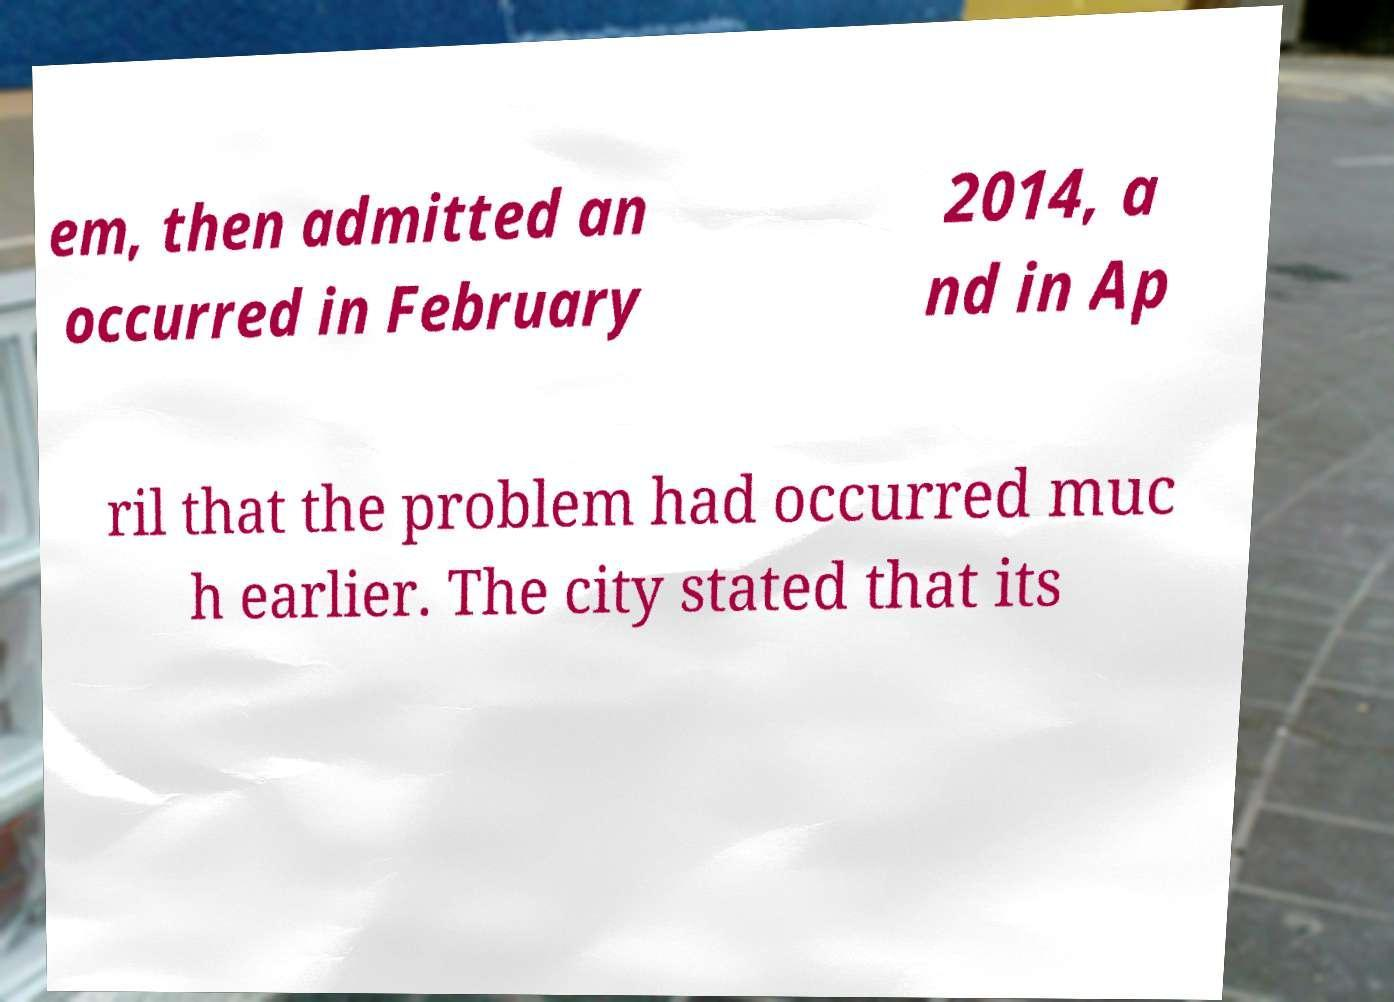Can you read and provide the text displayed in the image?This photo seems to have some interesting text. Can you extract and type it out for me? em, then admitted an occurred in February 2014, a nd in Ap ril that the problem had occurred muc h earlier. The city stated that its 